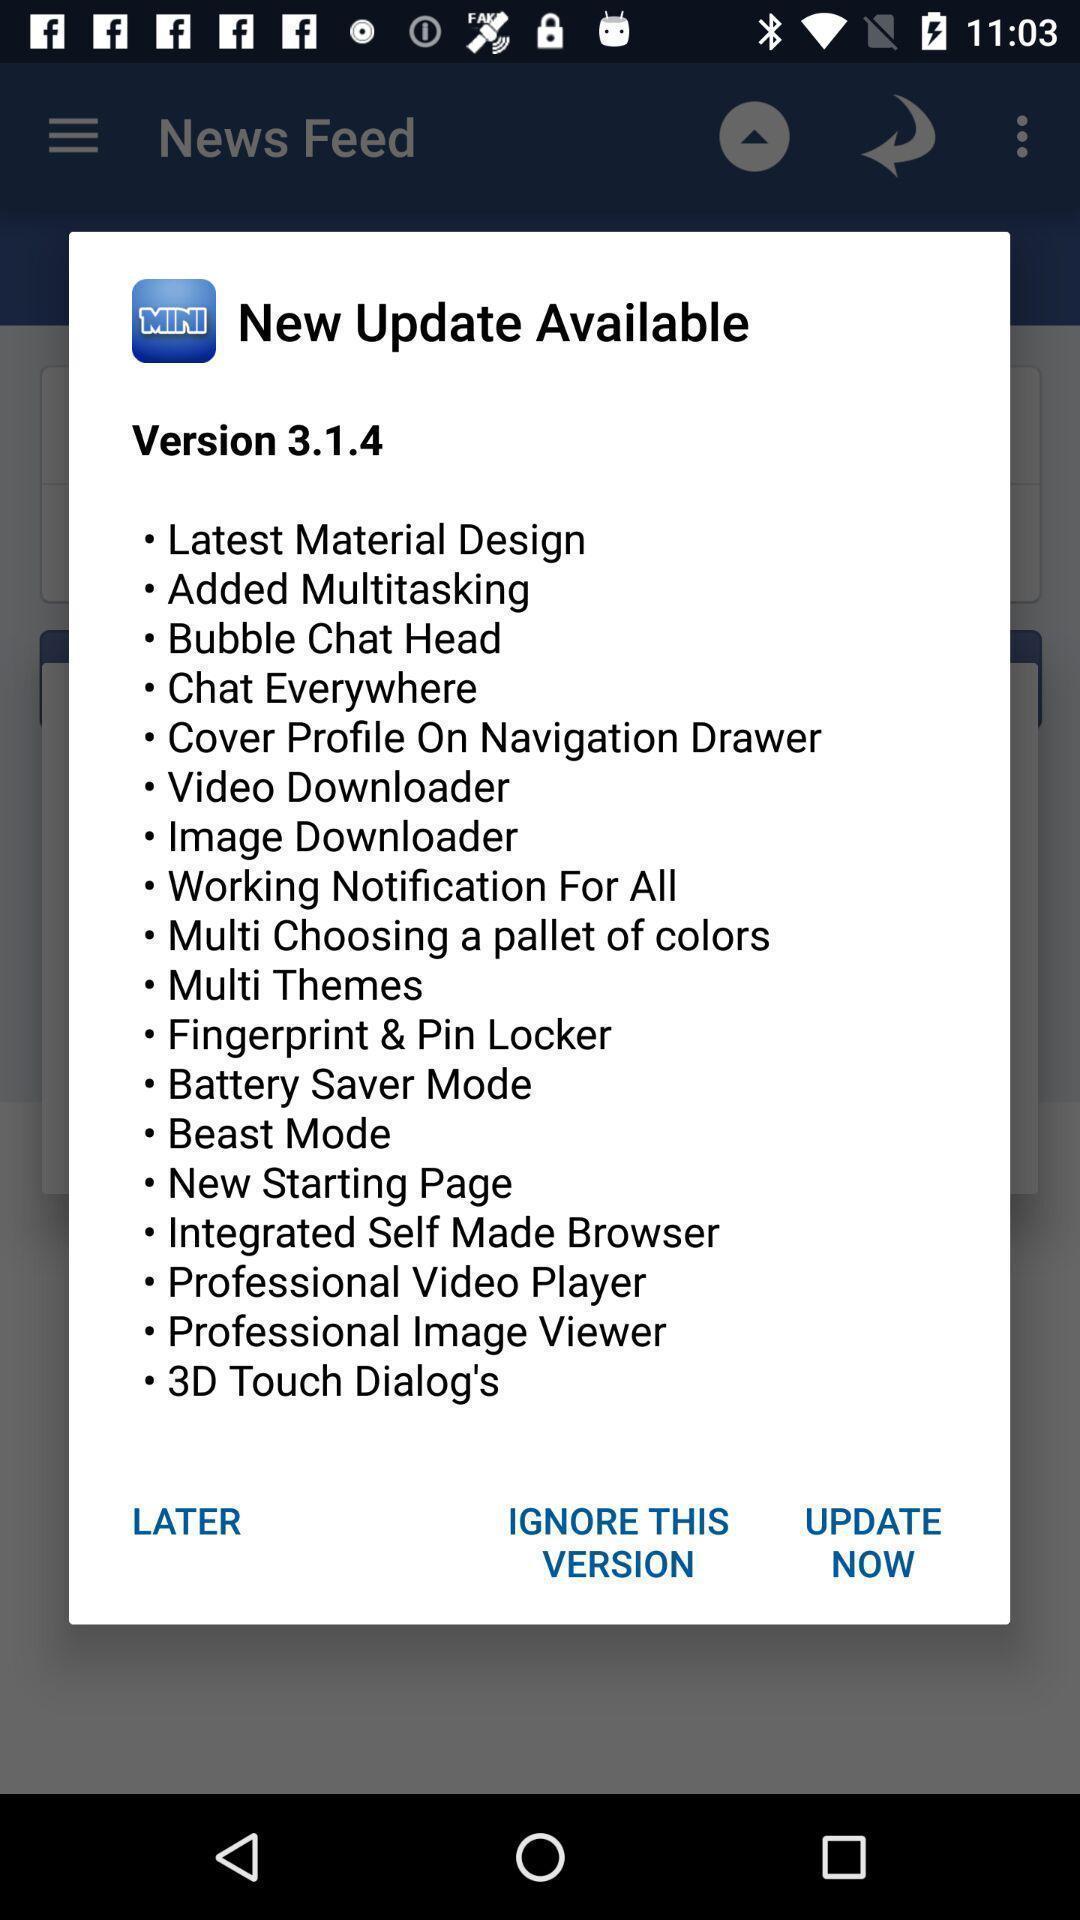Describe this image in words. Pop-up shows list of new update details. 